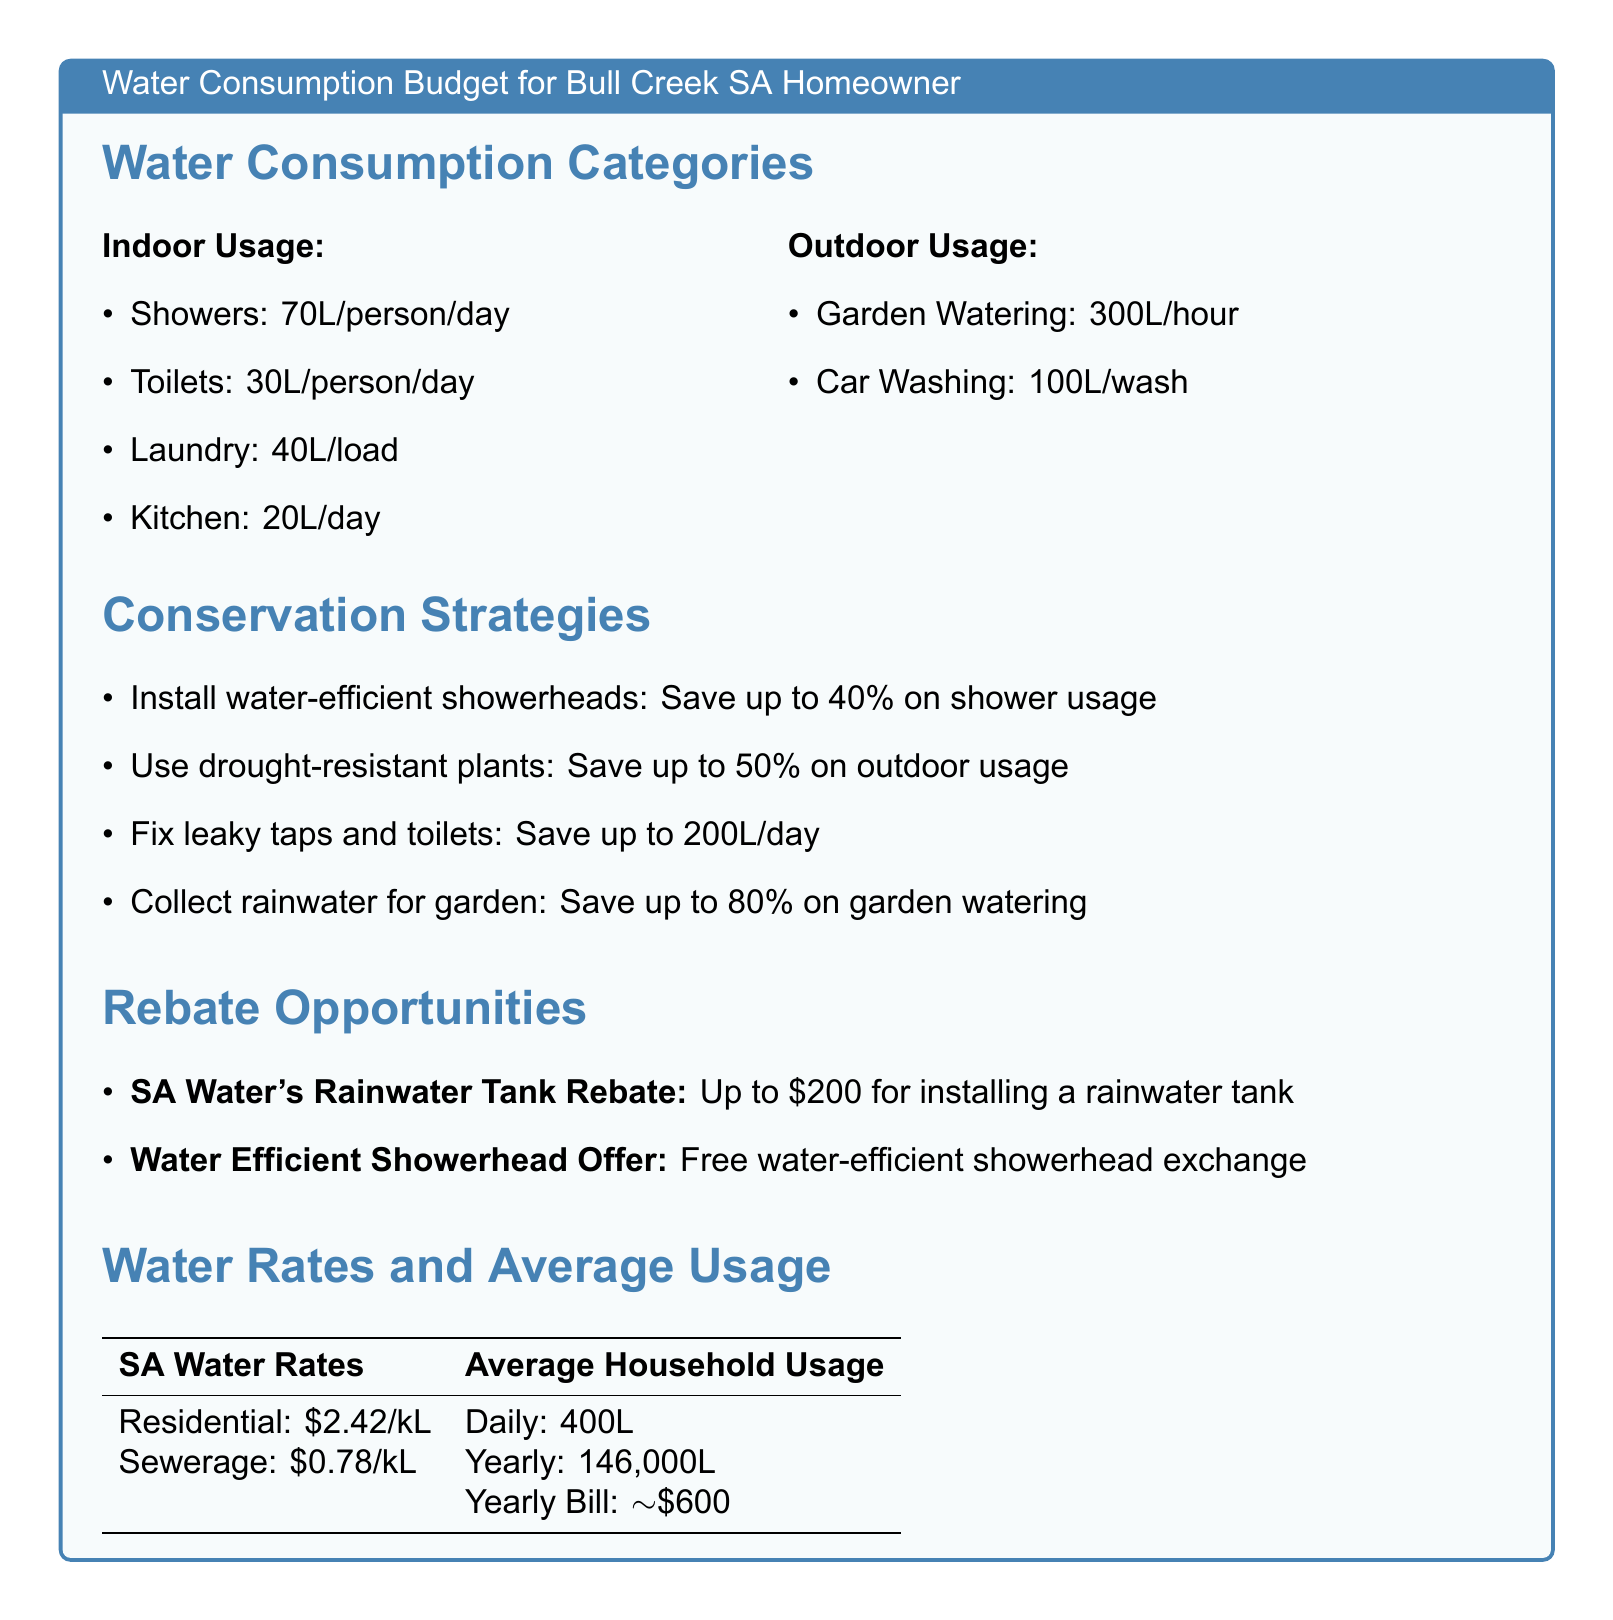What is the daily average water usage per household? The document states the daily average household usage is 400L.
Answer: 400L How much can you save by fixing leaky taps and toilets? The document mentions that fixing leaky taps and toilets can save up to 200L/day.
Answer: 200L/day What is the rebate amount for installing a rainwater tank? According to the document, the rebate for installing a rainwater tank is up to $200.
Answer: $200 What type of plants can help save water outdoors? The document suggests using drought-resistant plants to save on outdoor usage.
Answer: Drought-resistant plants What is the cost of residential water rates per kiloliter? The document specifies that the residential water rates are $2.42/kL.
Answer: $2.42/kL How much water can be saved by collecting rainwater for the garden? The document indicates that collecting rainwater can save up to 80% on garden watering.
Answer: 80% What is the yearly bill for average household water usage? According to the document, the yearly bill for average household usage is approximately $600.
Answer: Approximately $600 What is the water-efficient showerhead offer? The document states the offer is a free water-efficient showerhead exchange.
Answer: Free water-efficient showerhead exchange How much water is used per person for showers? The document lists that showers use 70L/person/day.
Answer: 70L/person/day 